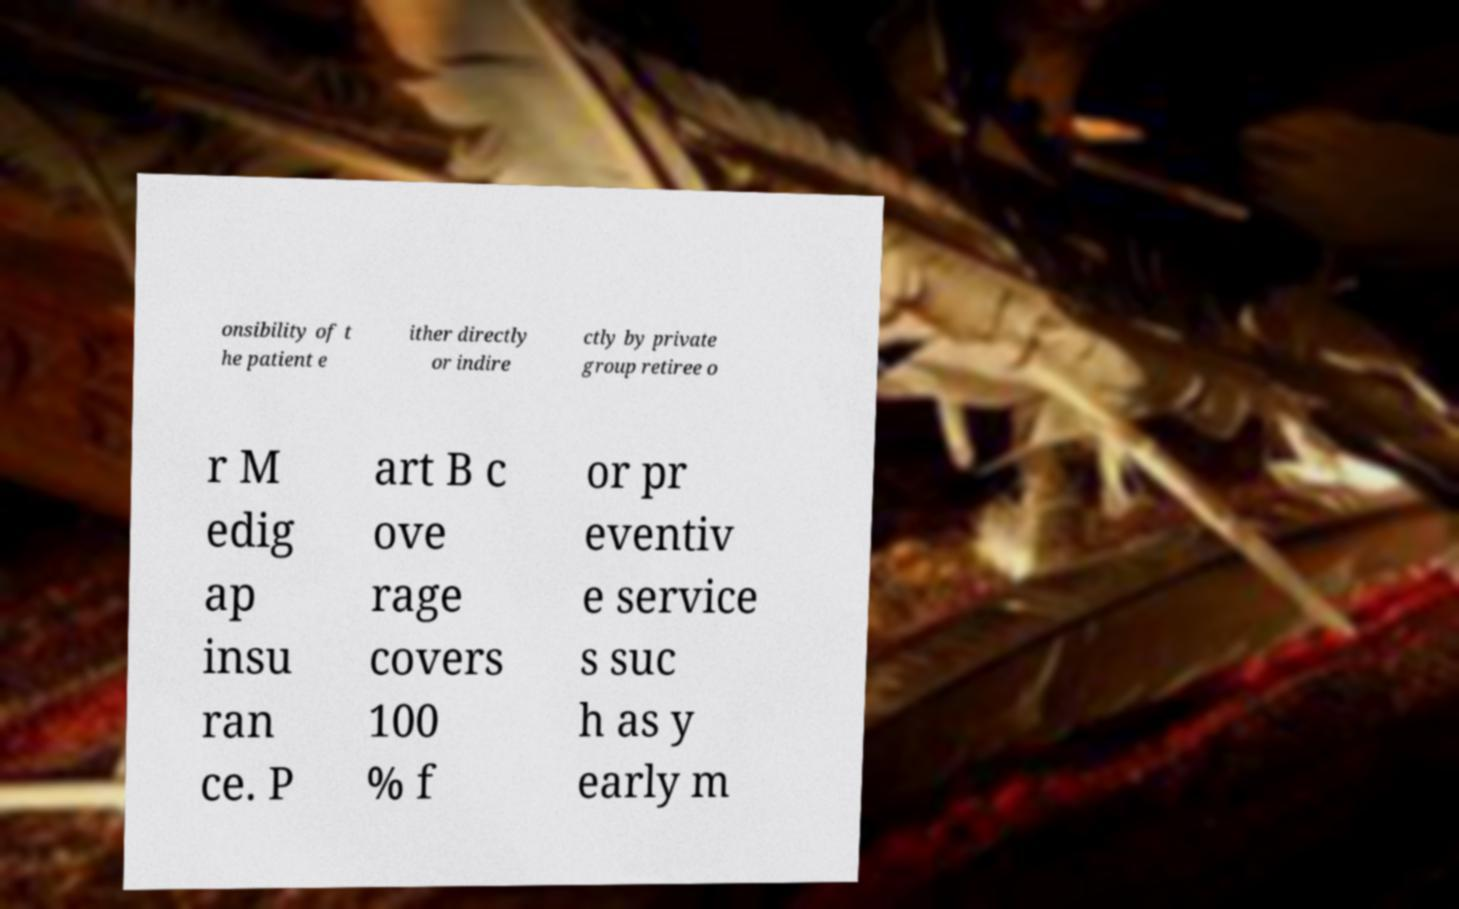I need the written content from this picture converted into text. Can you do that? onsibility of t he patient e ither directly or indire ctly by private group retiree o r M edig ap insu ran ce. P art B c ove rage covers 100 % f or pr eventiv e service s suc h as y early m 